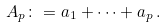<formula> <loc_0><loc_0><loc_500><loc_500>A _ { p } \colon = a _ { 1 } + \cdots + a _ { p } \, .</formula> 